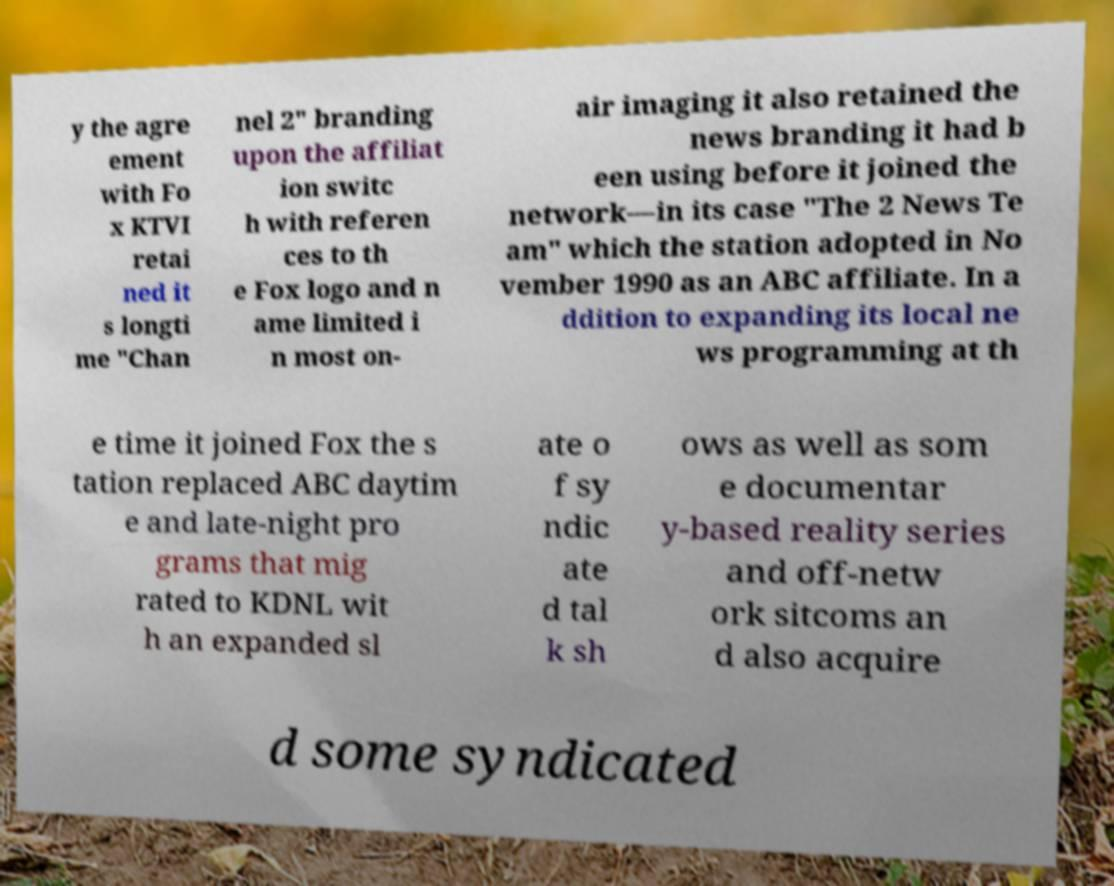I need the written content from this picture converted into text. Can you do that? y the agre ement with Fo x KTVI retai ned it s longti me "Chan nel 2" branding upon the affiliat ion switc h with referen ces to th e Fox logo and n ame limited i n most on- air imaging it also retained the news branding it had b een using before it joined the network—in its case "The 2 News Te am" which the station adopted in No vember 1990 as an ABC affiliate. In a ddition to expanding its local ne ws programming at th e time it joined Fox the s tation replaced ABC daytim e and late-night pro grams that mig rated to KDNL wit h an expanded sl ate o f sy ndic ate d tal k sh ows as well as som e documentar y-based reality series and off-netw ork sitcoms an d also acquire d some syndicated 